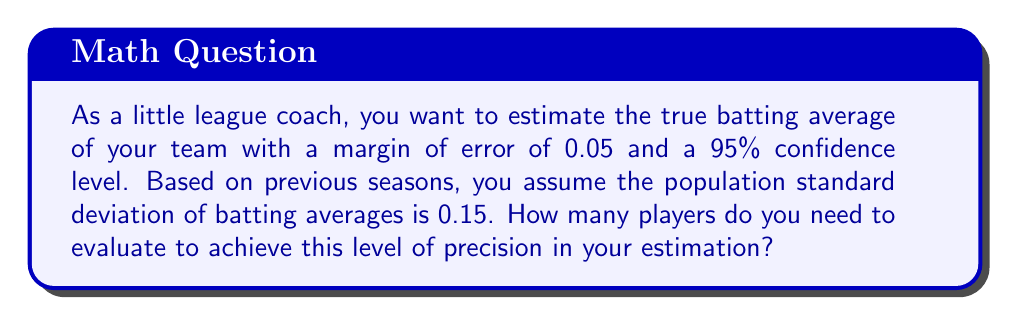Could you help me with this problem? Let's approach this step-by-step:

1) The formula for sample size determination for a confidence interval is:

   $$n = \left(\frac{z_{\alpha/2} \cdot \sigma}{E}\right)^2$$

   Where:
   $n$ = sample size
   $z_{\alpha/2}$ = critical value from the standard normal distribution
   $\sigma$ = population standard deviation
   $E$ = margin of error

2) We're given:
   - Confidence level = 95%, so $\alpha = 0.05$
   - Margin of error, $E = 0.05$
   - Population standard deviation, $\sigma = 0.15$

3) For a 95% confidence level, $z_{\alpha/2} = 1.96$

4) Now, let's substitute these values into our formula:

   $$n = \left(\frac{1.96 \cdot 0.15}{0.05}\right)^2$$

5) Simplify:
   $$n = (1.96 \cdot 3)^2 = 5.88^2 = 34.5744$$

6) Since we can't evaluate a fractional number of players, we round up to the nearest whole number.
Answer: 35 players 